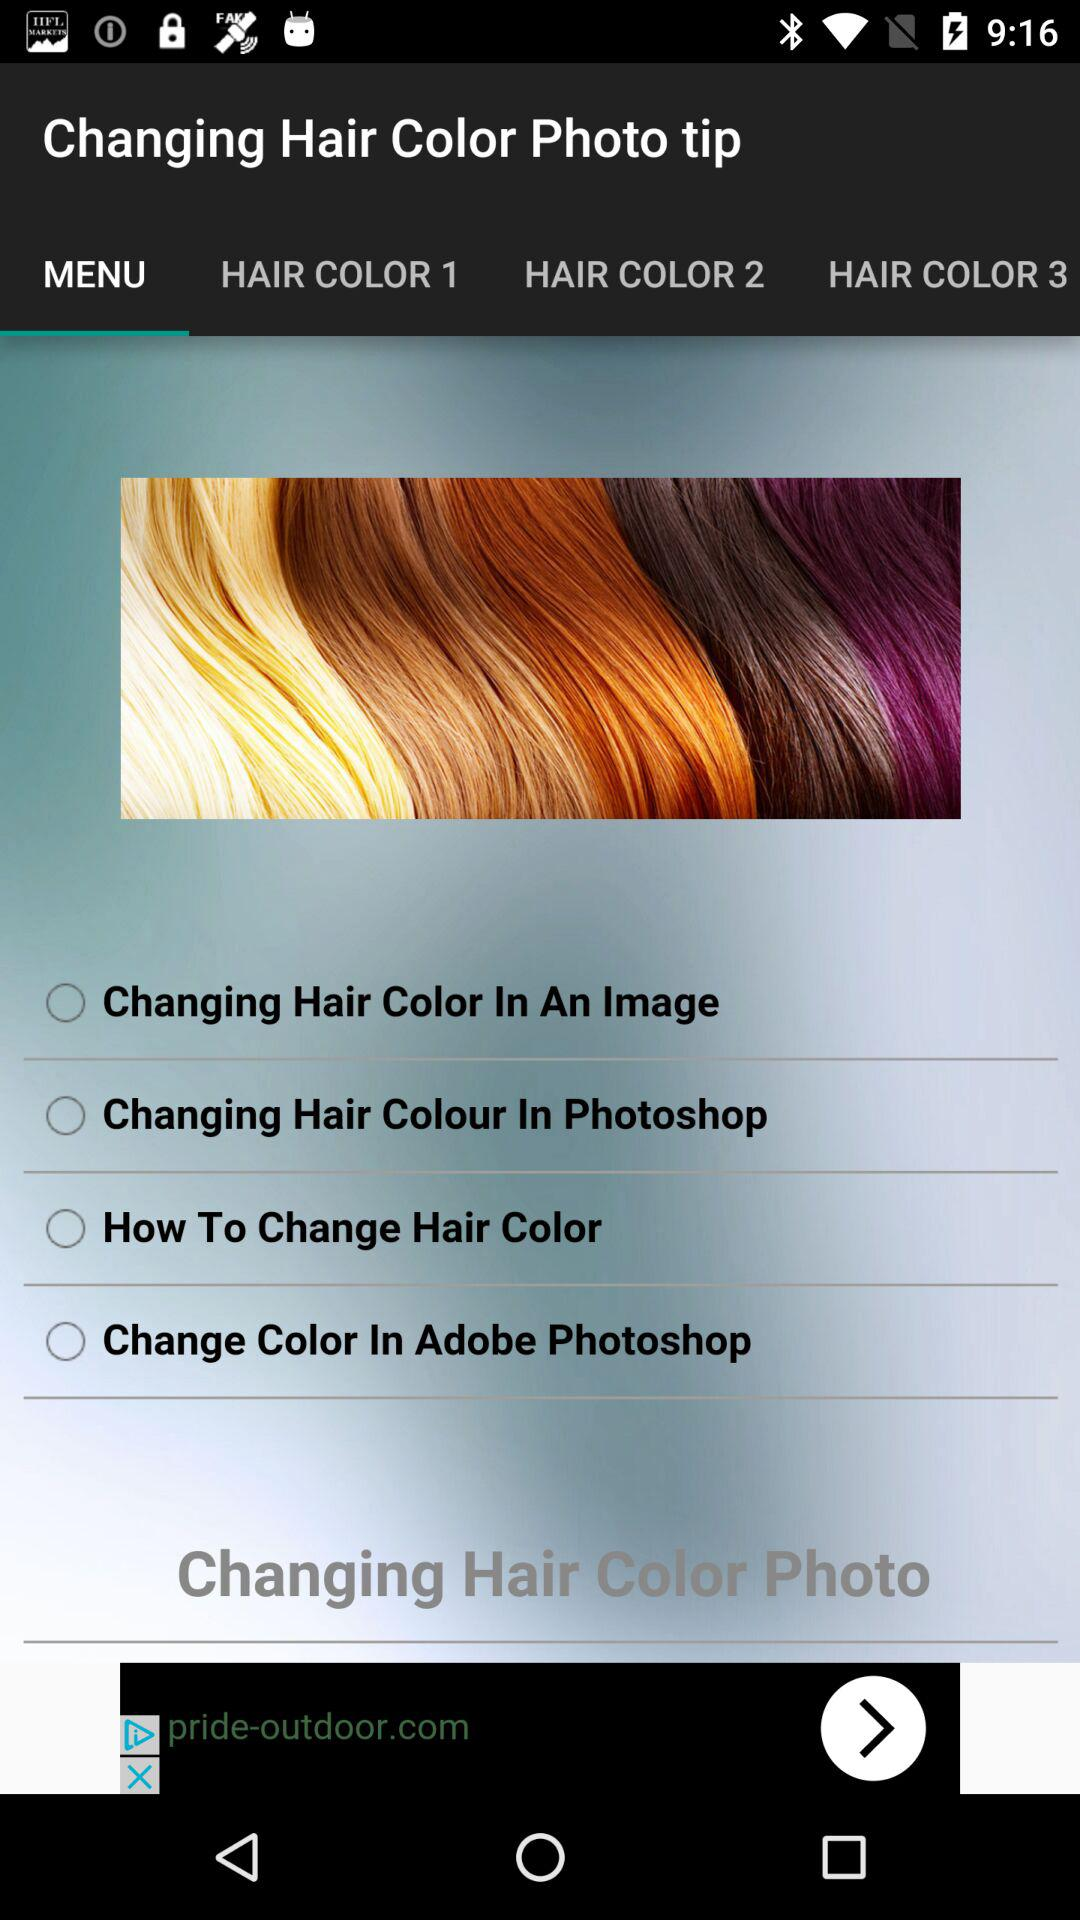Which tab is selected? The selected tab is "MENU". 